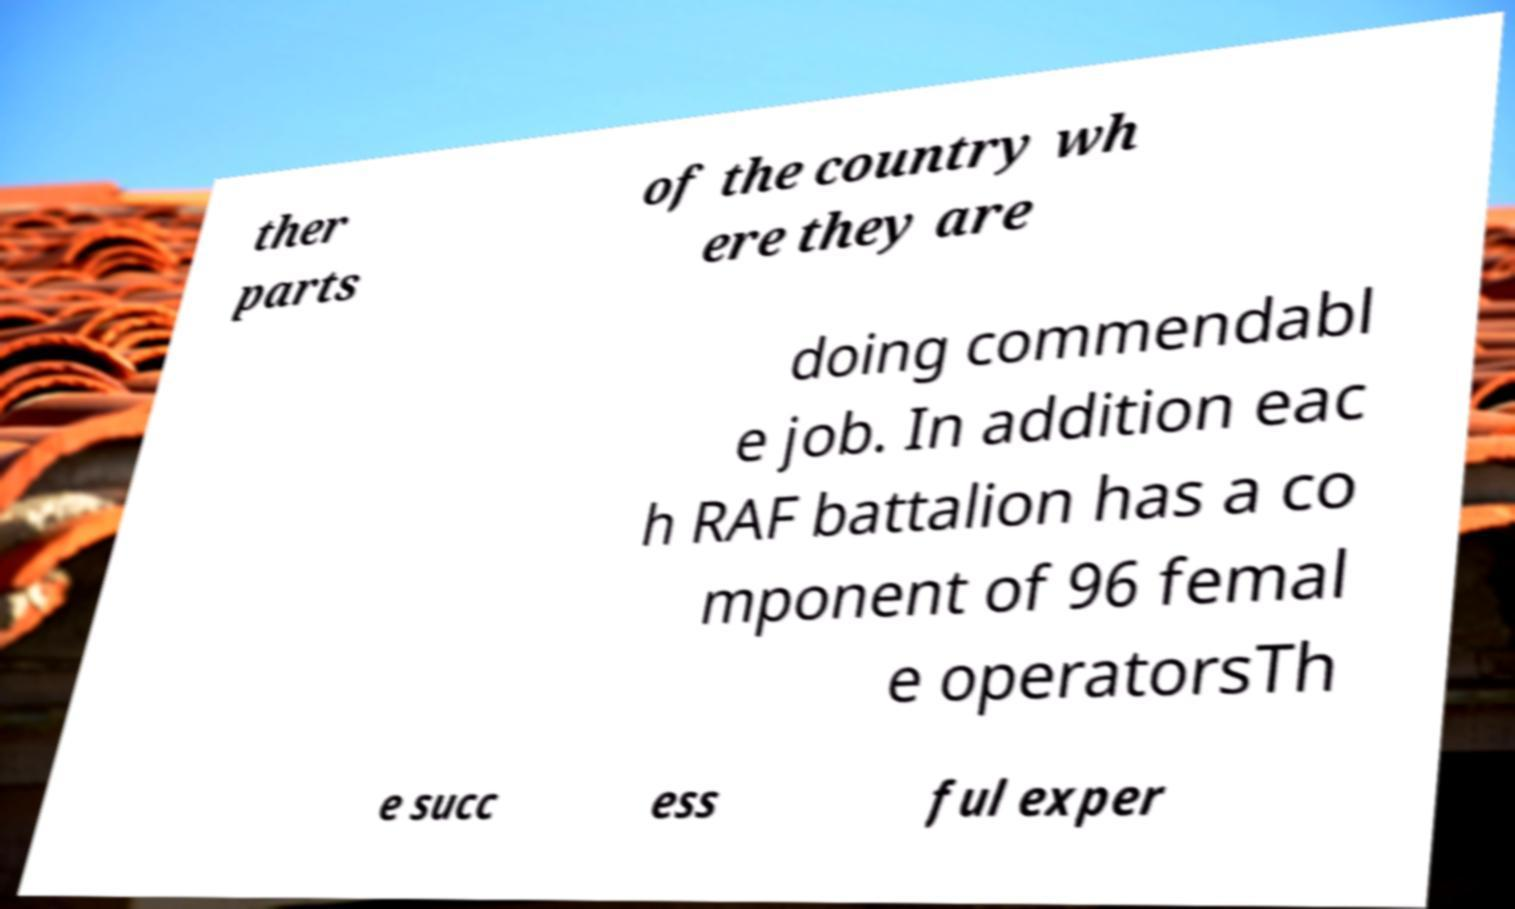Please read and relay the text visible in this image. What does it say? ther parts of the country wh ere they are doing commendabl e job. In addition eac h RAF battalion has a co mponent of 96 femal e operatorsTh e succ ess ful exper 